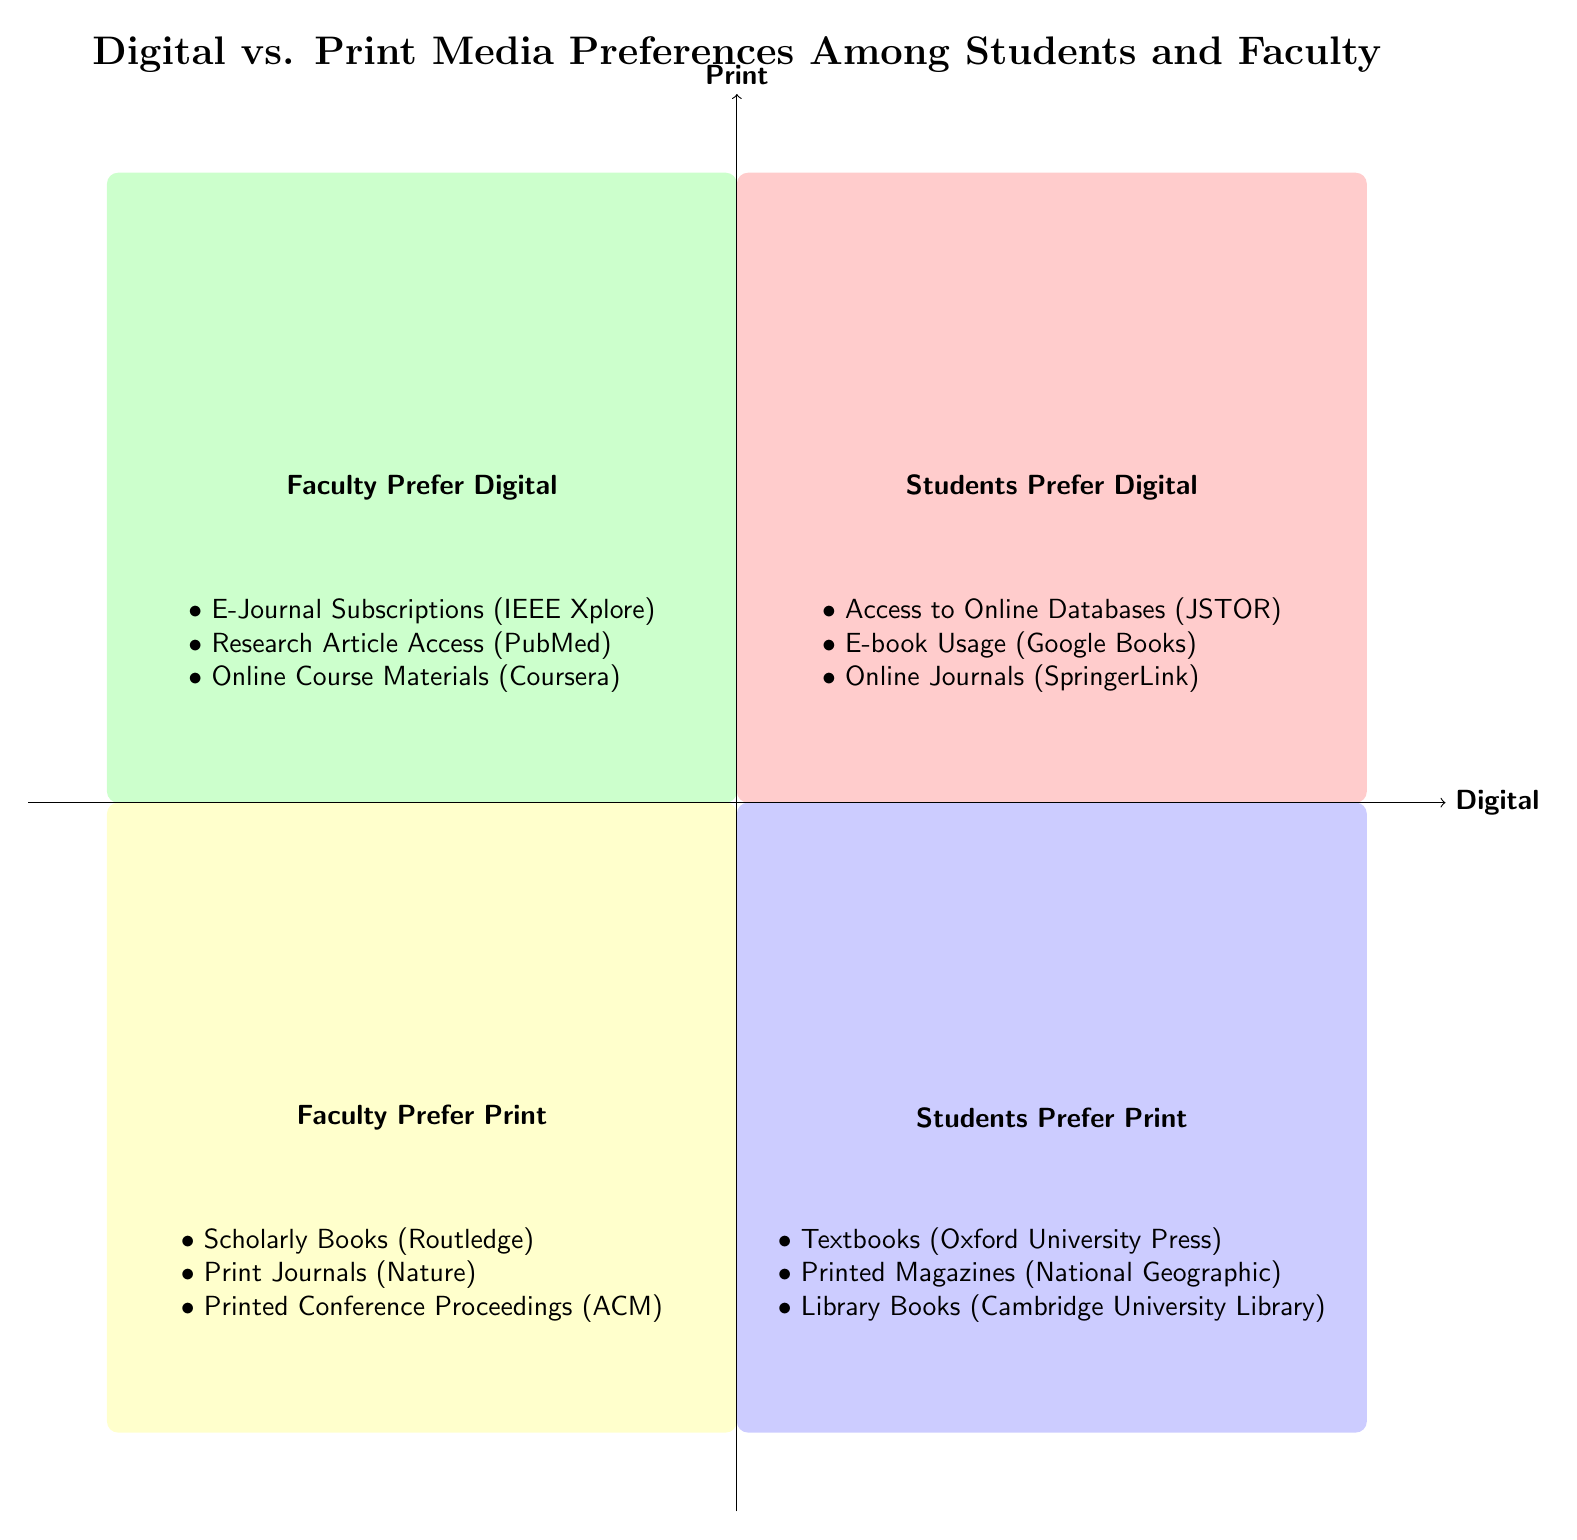What's the category of Q1? Q1 is labeled as "Students Prefer Digital," indicating that this quadrant represents elements related to digital media preferences among students.
Answer: Students Prefer Digital How many elements are in Q2? Q2 contains three elements: E-Journal Subscriptions, Research Article Access, and Online Course Materials, making it a total of three elements.
Answer: 3 Which entity is associated with printed magazines? The element in Q3 that mentions printed magazines is associated with the entity National Geographic.
Answer: National Geographic What type of materials do faculty prefer according to Q4? Q4 shows that faculty prefer print materials, and specifically includes elements such as Scholarly Books, Print Journals, and Printed Conference Proceedings.
Answer: Print materials Which quadrant contains "E-book Usage"? "E-book Usage" is located in Q1, which represents the category "Students Prefer Digital."
Answer: Q1 Which category has the access to JSTOR mentioned? JSTOR is included in the category of Q1, which is centered around "Students Prefer Digital."
Answer: Q1 What type of journals do faculty prefer according to Q4? Q4 indicates that faculty prefer Print Journals, which signifies that they value printed forms of journal literature.
Answer: Print Journals How many quadrants show students' preferences? There are two quadrants, Q1 and Q3, that display students' preferences, one for digital and the other for print.
Answer: 2 What entity is listed for library books in Q3? The element related to library books in Q3 is associated with the entity Cambridge University Library.
Answer: Cambridge University Library 